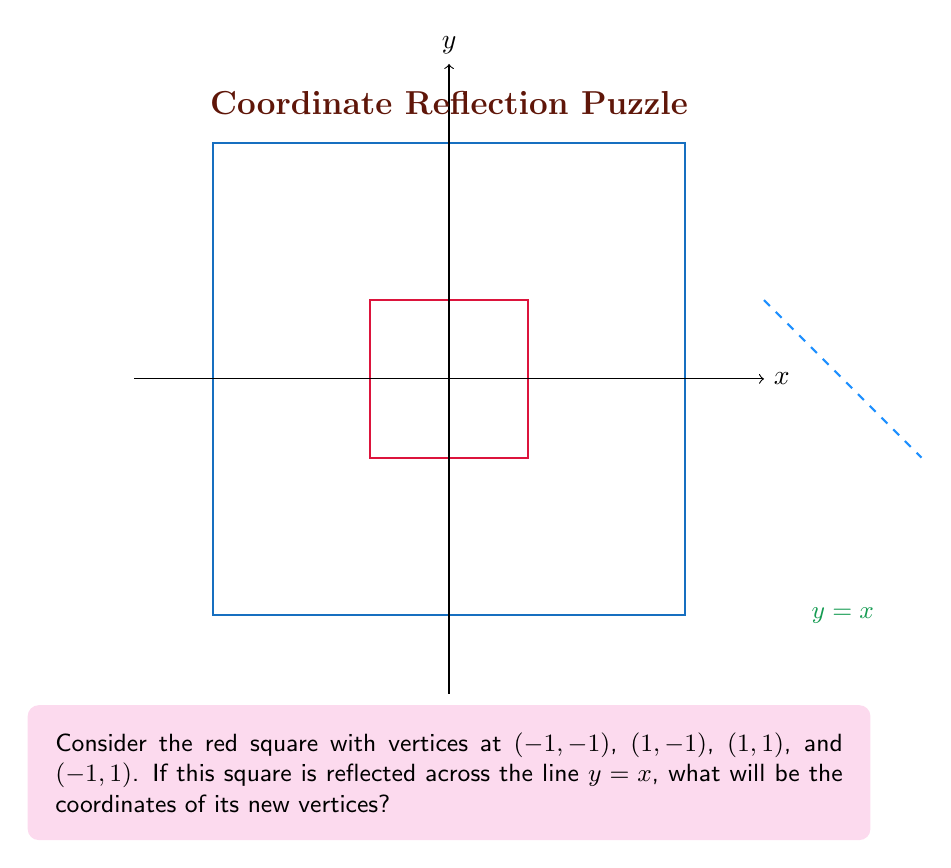Could you help me with this problem? Let's approach this step-by-step:

1) The line $y = x$ is the diagonal line that passes through the origin and has a 45-degree angle with both axes.

2) To reflect a point $(a,b)$ across the line $y = x$, we swap its x and y coordinates. The new point becomes $(b,a)$.

3) Let's reflect each vertex of the square:

   a) $(-1,-1)$ remains $(-1,-1)$ as it's on the line $y = x$
   b) $(1,-1)$ becomes $(-1,1)$
   c) $(1,1)$ remains $(1,1)$ as it's on the line $y = x$
   d) $(-1,1)$ becomes $(1,-1)$

4) We can visualize the transformation:

   [asy]
   unitsize(1cm);
   draw((-3,-3)--(3,-3)--(3,3)--(-3,3)--cycle);
   draw((-1,-1)--(1,-1)--(1,1)--(-1,1)--cycle, red+dashed);
   draw((-1,-1)--(-1,1)--(1,1)--(1,-1)--cycle, blue);
   draw((-4,0)--(4,0), arrow=Arrow(TeXHead));
   draw((0,-4)--(0,4), arrow=Arrow(TeXHead));
   draw((-4,-4)--(4,4), green);
   label("x", (4,0), E);
   label("y", (0,4), N);
   label("y = x", (3,3), NE, green);
   [/asy]

   The original square is shown in dashed red, and the reflected square is in blue.

5) The new vertices of the reflected square are $(-1,-1)$, $(-1,1)$, $(1,1)$, and $(1,-1)$.
Answer: $(-1,-1)$, $(-1,1)$, $(1,1)$, $(1,-1)$ 